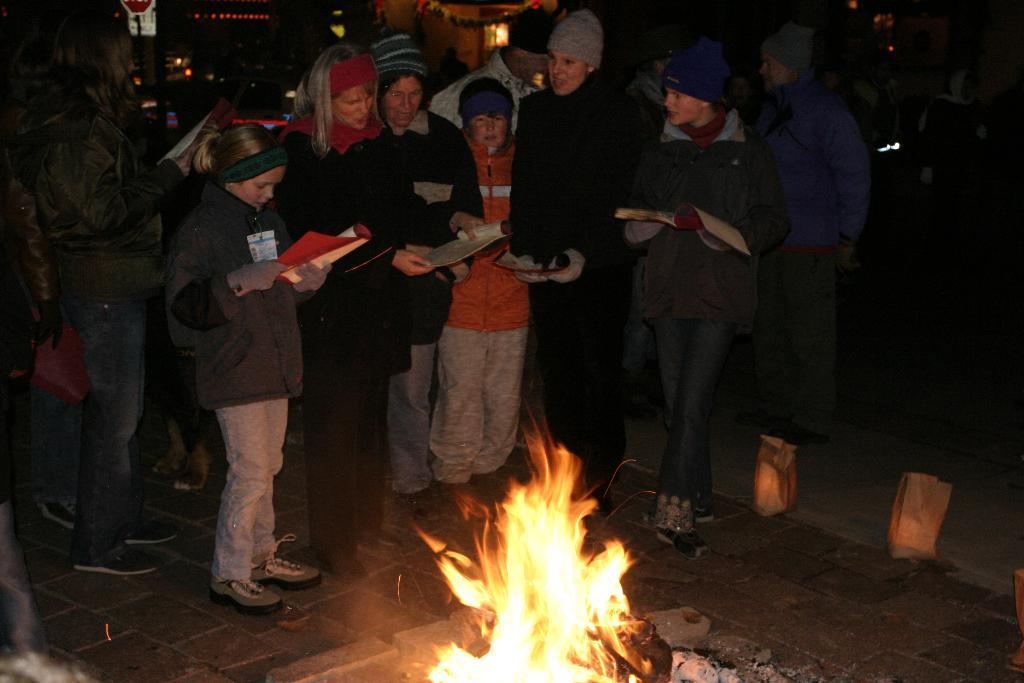Who or what is present in the image? There are people in the image. What are the people holding in the image? The people are holding books. Where are the people standing in the image? The people are standing on the ground. What can be seen at the bottom of the image? There is fire visible at the bottom of the image. Are the people in the image sleeping or twisting? The provided facts do not mention anything about the people sleeping or twisting; they are simply holding books while standing on the ground. What type of punishment is being administered to the people in the image? There is no indication of any punishment being administered to the people in the image; they are just holding books and standing on the ground. 